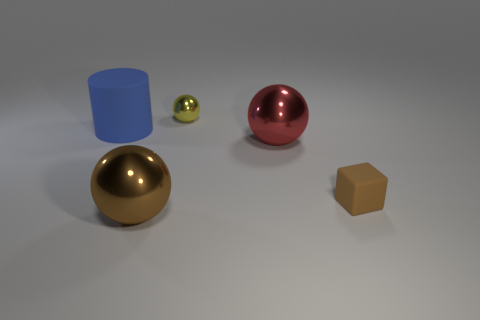Subtract all big balls. How many balls are left? 1 Add 2 red shiny things. How many objects exist? 7 Subtract all red spheres. How many spheres are left? 2 Subtract 1 cylinders. How many cylinders are left? 0 Subtract all yellow blocks. Subtract all brown cylinders. How many blocks are left? 1 Add 2 large red shiny spheres. How many large red shiny spheres are left? 3 Add 1 large matte cylinders. How many large matte cylinders exist? 2 Subtract 0 blue blocks. How many objects are left? 5 Subtract all spheres. How many objects are left? 2 Subtract all purple cubes. How many red spheres are left? 1 